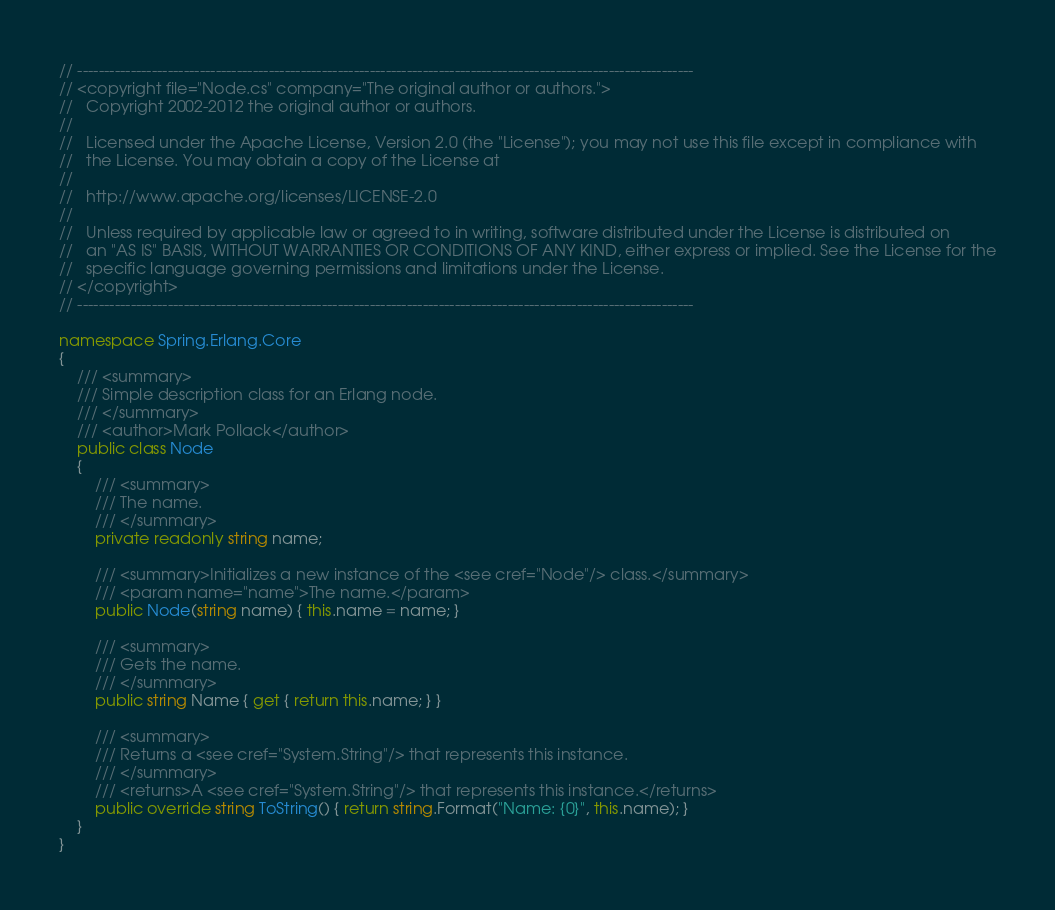Convert code to text. <code><loc_0><loc_0><loc_500><loc_500><_C#_>// --------------------------------------------------------------------------------------------------------------------
// <copyright file="Node.cs" company="The original author or authors.">
//   Copyright 2002-2012 the original author or authors.
//   
//   Licensed under the Apache License, Version 2.0 (the "License"); you may not use this file except in compliance with
//   the License. You may obtain a copy of the License at
//   
//   http://www.apache.org/licenses/LICENSE-2.0
//   
//   Unless required by applicable law or agreed to in writing, software distributed under the License is distributed on
//   an "AS IS" BASIS, WITHOUT WARRANTIES OR CONDITIONS OF ANY KIND, either express or implied. See the License for the
//   specific language governing permissions and limitations under the License.
// </copyright>
// --------------------------------------------------------------------------------------------------------------------

namespace Spring.Erlang.Core
{
    /// <summary>
    /// Simple description class for an Erlang node. 
    /// </summary>
    /// <author>Mark Pollack</author>
    public class Node
    {
        /// <summary>
        /// The name.
        /// </summary>
        private readonly string name;

        /// <summary>Initializes a new instance of the <see cref="Node"/> class.</summary>
        /// <param name="name">The name.</param>
        public Node(string name) { this.name = name; }

        /// <summary>
        /// Gets the name.
        /// </summary>
        public string Name { get { return this.name; } }

        /// <summary>
        /// Returns a <see cref="System.String"/> that represents this instance.
        /// </summary>
        /// <returns>A <see cref="System.String"/> that represents this instance.</returns>
        public override string ToString() { return string.Format("Name: {0}", this.name); }
    }
}
</code> 